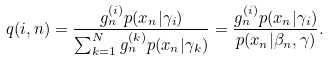<formula> <loc_0><loc_0><loc_500><loc_500>q ( i , n ) = \frac { g _ { n } ^ { ( i ) } p ( x _ { n } | \gamma _ { i } ) } { \sum _ { k = 1 } ^ { N } g _ { n } ^ { ( k ) } p ( x _ { n } | \gamma _ { k } ) } = \frac { g _ { n } ^ { ( i ) } p ( x _ { n } | \gamma _ { i } ) } { p ( x _ { n } | \beta _ { n } , \gamma ) } .</formula> 